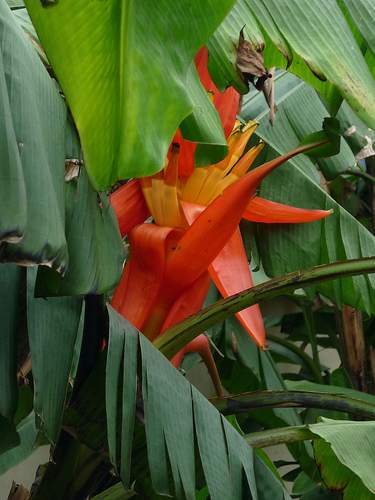<image>
Is there a flower in front of the leaf? No. The flower is not in front of the leaf. The spatial positioning shows a different relationship between these objects. 